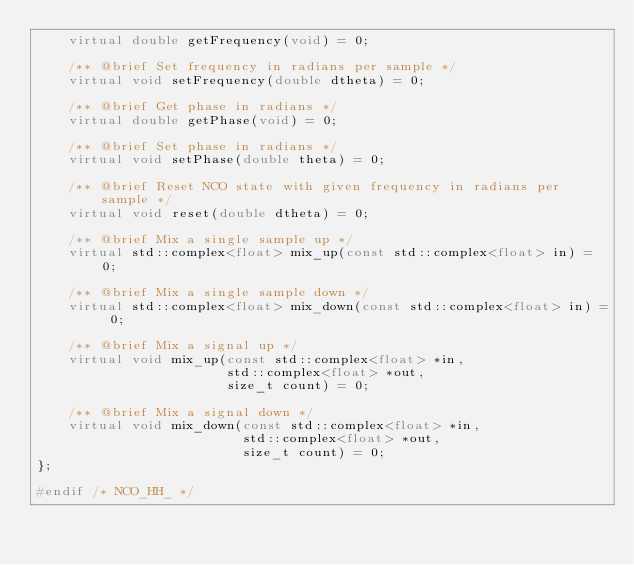Convert code to text. <code><loc_0><loc_0><loc_500><loc_500><_C++_>    virtual double getFrequency(void) = 0;

    /** @brief Set frequency in radians per sample */
    virtual void setFrequency(double dtheta) = 0;

    /** @brief Get phase in radians */
    virtual double getPhase(void) = 0;

    /** @brief Set phase in radians */
    virtual void setPhase(double theta) = 0;

    /** @brief Reset NCO state with given frequency in radians per sample */
    virtual void reset(double dtheta) = 0;

    /** @brief Mix a single sample up */
    virtual std::complex<float> mix_up(const std::complex<float> in) = 0;

    /** @brief Mix a single sample down */
    virtual std::complex<float> mix_down(const std::complex<float> in) = 0;

    /** @brief Mix a signal up */
    virtual void mix_up(const std::complex<float> *in,
                        std::complex<float> *out,
                        size_t count) = 0;

    /** @brief Mix a signal down */
    virtual void mix_down(const std::complex<float> *in,
                          std::complex<float> *out,
                          size_t count) = 0;
};

#endif /* NCO_HH_ */
</code> 